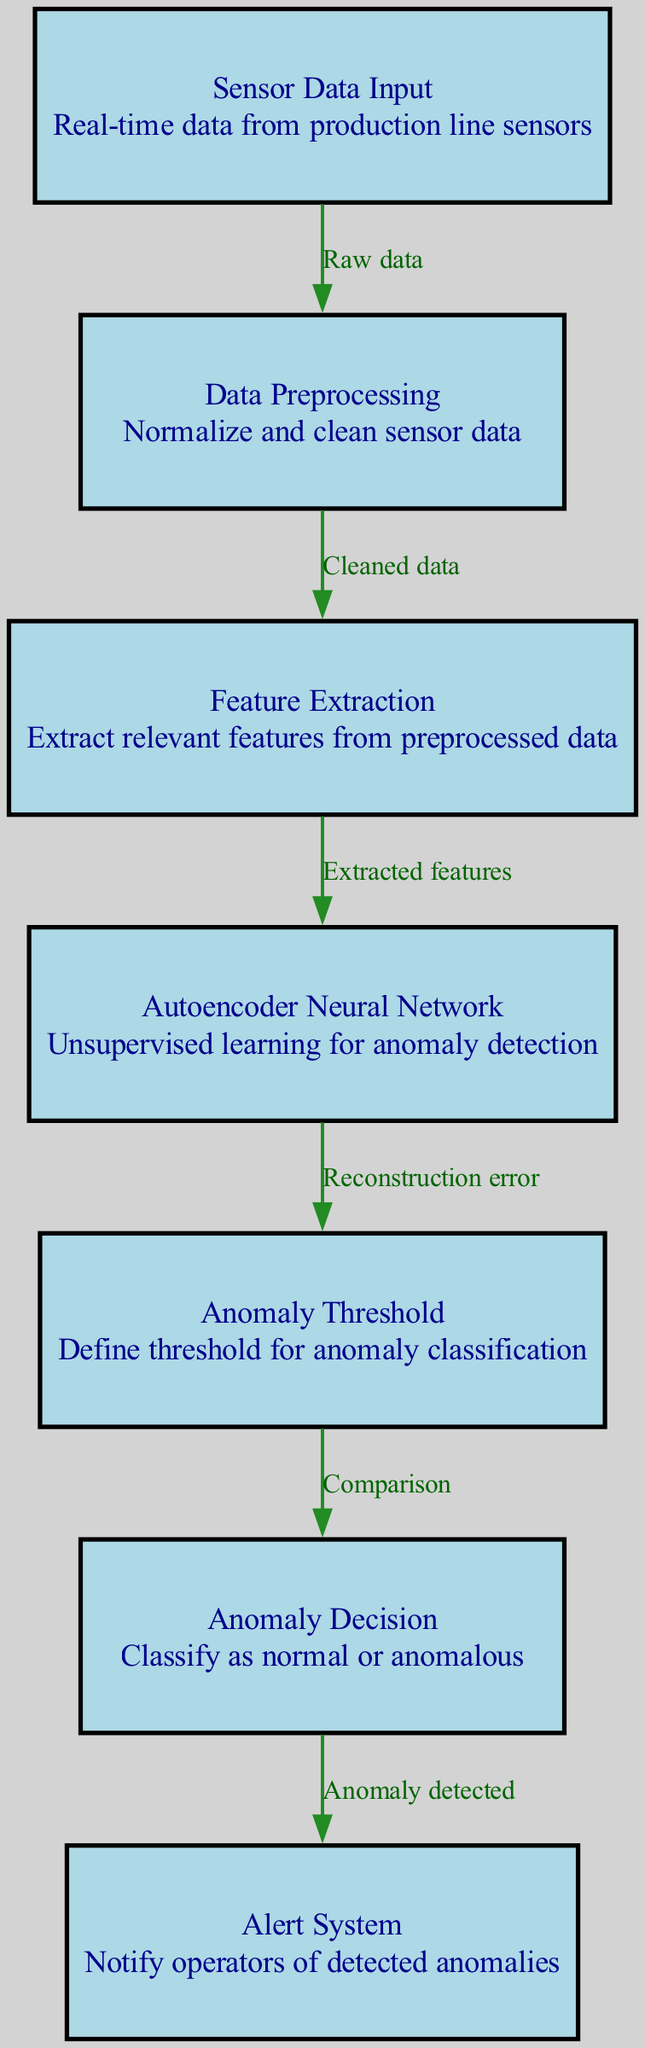What is the first step in the diagram? The first step in the diagram is "Sensor Data Input," which represents the raw data coming from production line sensors.
Answer: Sensor Data Input How many nodes are present in the diagram? By counting the various labeled boxes in the diagram, we find that there are a total of 7 nodes.
Answer: 7 What is the purpose of the Autoencoder Neural Network? The Autoencoder Neural Network is used for unsupervised learning to detect anomalies in the manufacturing process.
Answer: Unsupervised learning for anomaly detection What does the Anomaly Threshold node do? The Anomaly Threshold node defines the threshold that is used for classifying data as normal or anomalous based on the reconstruction error output from the autoencoder.
Answer: Define threshold for anomaly classification What is the output from the Autoencoder Node? The output from the Autoencoder Node is the "Reconstruction error," which is calculated to determine if the data is anomalous.
Answer: Reconstruction error What type of data is fed into the Data Preprocessing node? The type of data fed into the Data Preprocessing node is "Cleaned data" that has been normalized and cleaned from the raw sensor input.
Answer: Cleaned data Which node notifies operators of detected anomalies? The node that notifies operators of detected anomalies is labeled as the "Alert System."
Answer: Alert System How does the diagram determine whether data is classified as normal or anomalous? The classification of data as normal or anomalous is determined by comparing the reconstruction error against the defined anomaly threshold in the Anomaly Decision node.
Answer: Comparison 